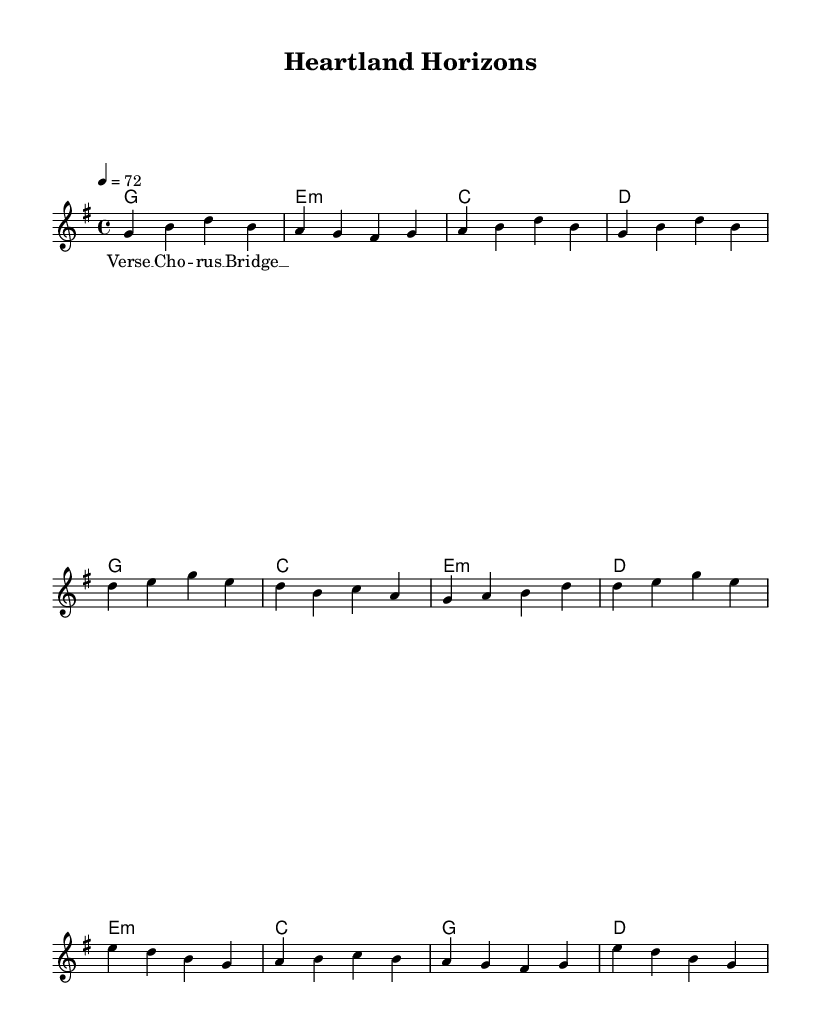What is the key signature of this music? The key signature is G major, which has one sharp (F#). This is indicated at the beginning of the score where the key signature is displayed.
Answer: G major What is the time signature of this music? The time signature is 4/4, which is shown at the beginning of the score right after the key signature. This implies there are four beats in a measure.
Answer: 4/4 What is the tempo marking for this piece? The tempo marking indicates 72 beats per minute, which is explicitly stated as "4 = 72" in the score. This means each quarter note is played at a speed of 72 per minute.
Answer: 72 How many measures are in the verse section? The verse section consists of four measures as indicated by the sequence of notes that span from the start of the verse until it transitions into the chorus.
Answer: 4 What is the first chord of the chorus? The first chord of the chorus is G major, which can be determined by looking at the chord symbols above the melody in the chorus section.
Answer: G What is the structure of the song indicated in the lyrics? The structure of the song follows a pattern of Verse, Chorus, and Bridge, which is laid out clearly in the lyrics section of the score. This indicates a common verse-chorus-bridge format typically found in pop songs.
Answer: Verse, Chorus, Bridge How many different chords are used in the song? There are five distinct chords used throughout the piece: G, E minor, C, D, and A. By analyzing the chord symbols listed in the harmonies section, one can count the unique chords.
Answer: 5 